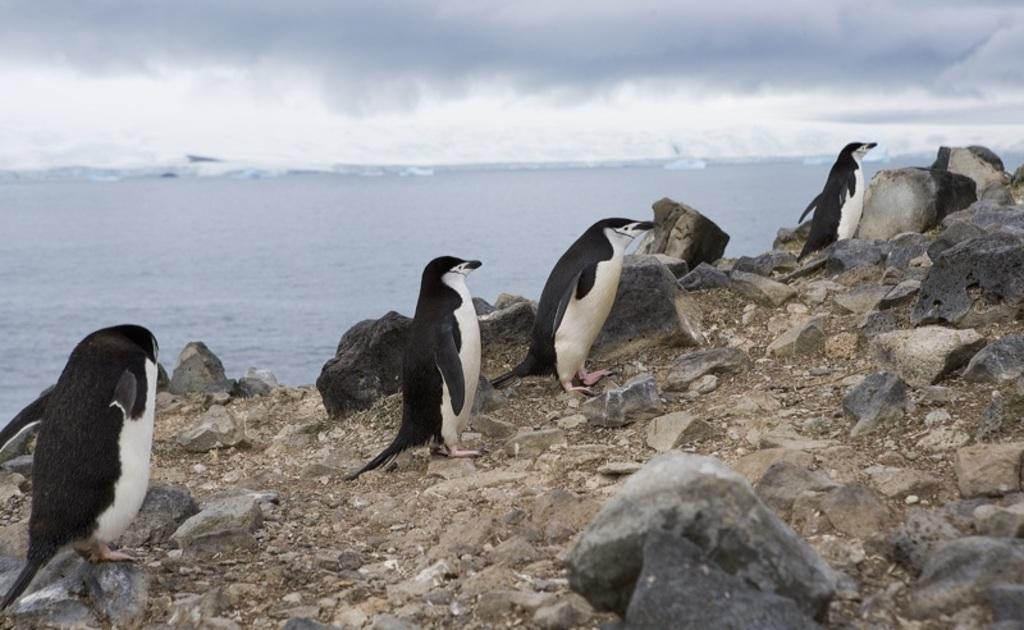What type of animals are in the image? There are penguins in the image. What is the penguins' position on the ground? The penguins are standing on the ground. What else can be seen on the ground in the image? There are rocks on the ground. What is visible in the background of the image? Water and the sky are visible in the image. What time does the father use his toothbrush in the image? There is no father or toothbrush present in the image; it features penguins standing on the ground with rocks, water, and the sky visible in the background. 